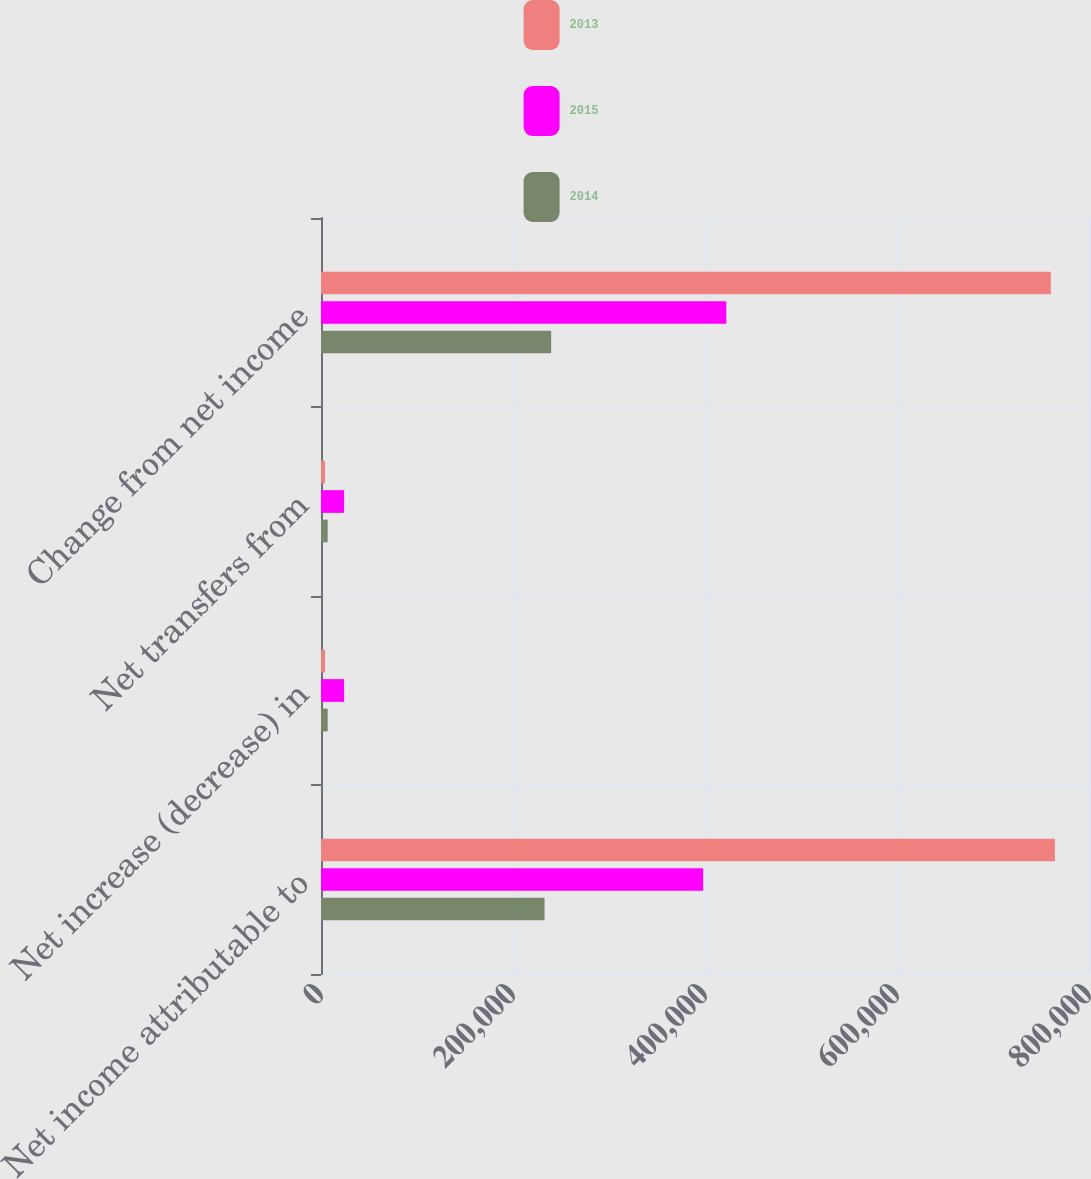<chart> <loc_0><loc_0><loc_500><loc_500><stacked_bar_chart><ecel><fcel>Net income attributable to<fcel>Net increase (decrease) in<fcel>Net transfers from<fcel>Change from net income<nl><fcel>2013<fcel>764465<fcel>4198<fcel>4198<fcel>760267<nl><fcel>2015<fcel>398097<fcel>24090<fcel>24090<fcel>422187<nl><fcel>2014<fcel>232850<fcel>6928<fcel>6928<fcel>239778<nl></chart> 